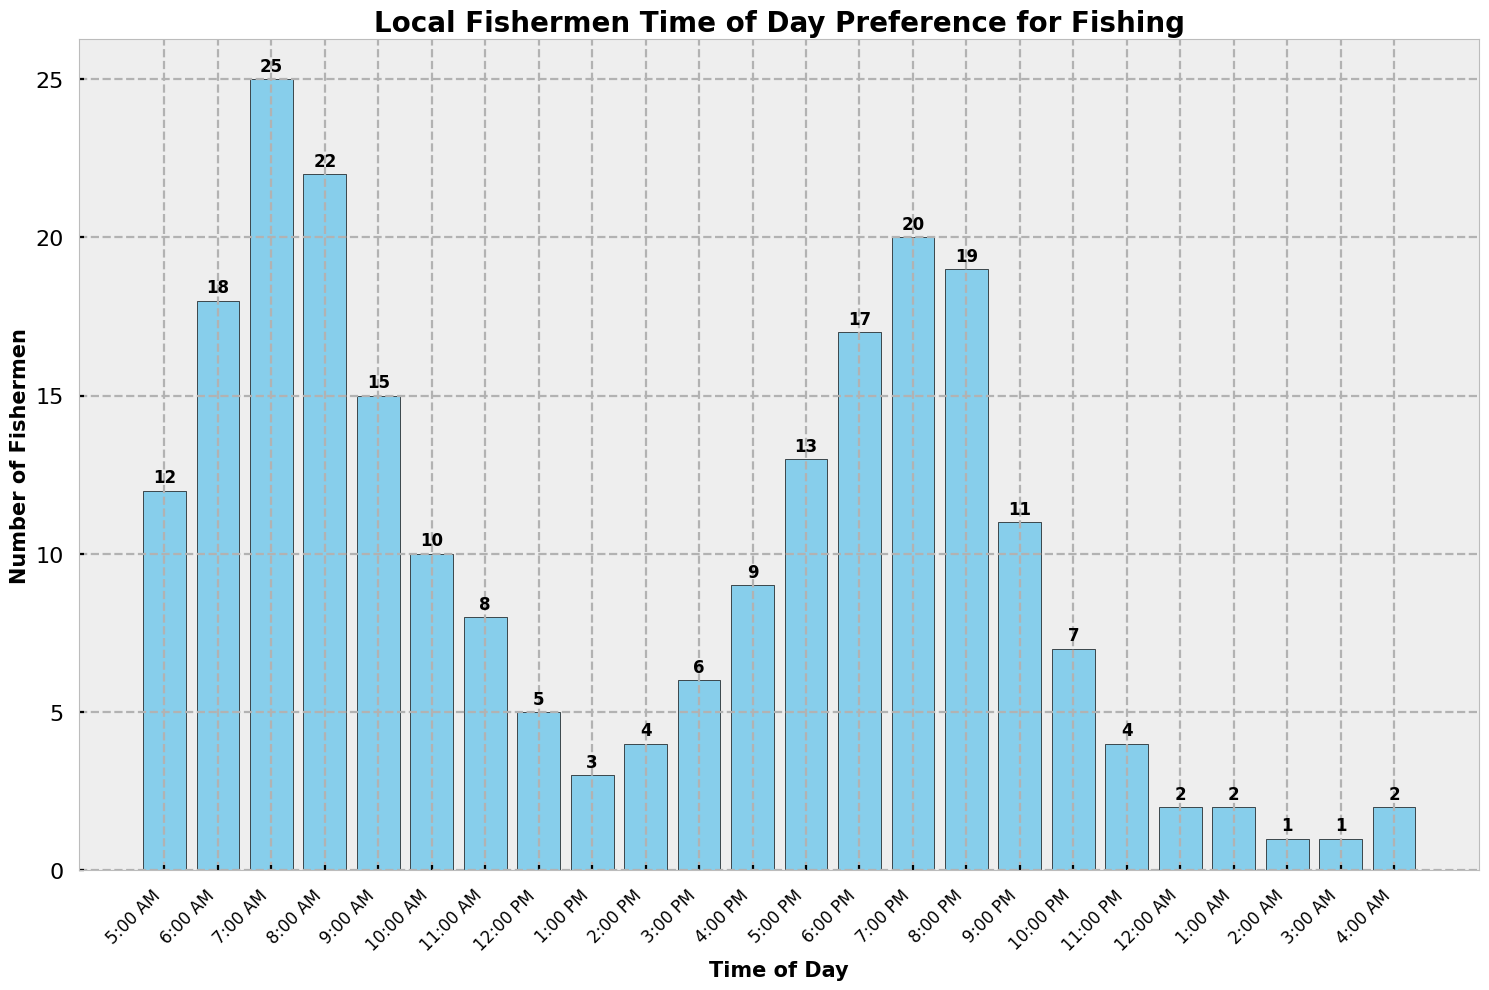What is the most preferred time of day for local fishermen to fish? The tallest bar on the histogram represents the time with the highest count of fishermen. The 7:00 AM bar is the tallest, showing that 25 fishermen prefer this time.
Answer: 7:00 AM How many fishermen prefer to fish between 5:00 AM and 7:00 AM? Sum the counts for the bars labeled 5:00 AM, 6:00 AM, and 7:00 AM. This is 12 + 18 + 25 = 55 fishermen.
Answer: 55 Is the count of fishermen who prefer to fish at 6:00 PM greater than those who prefer 10:00 PM? Compare the heights of the bars for 6:00 PM and 10:00 PM. 6:00 PM has 17 fishermen, while 10:00 PM has 7 fishermen. 17 is greater than 7.
Answer: Yes What is the difference in the number of fishermen between the most and least preferred times of day? Find the highest and lowest counts on the bars. The highest is at 7:00 AM with 25 fishermen, and the lowest counts are 2 fishermen at 12:00 AM, 1:00 AM, 2:00 AM, 3:00 AM, and 4:00 AM. The difference is 25 - 1 = 24.
Answer: 24 At what time range do fewer than 5 fishermen prefer to fish? Identify the bars with counts less than 5. These times are 12:00 PM (5 fishermen), 1:00 PM (3 fishermen), 2:00 PM (4 fishermen), 12:00 AM (2 fishermen), 1:00 AM (2 fishermen), 2:00 AM (1 fisherman), 3:00 AM (1 fisherman), and 4:00 AM (2 fishermen).
Answer: 12:00 PM to 2:00 PM and 12:00 AM to 4:00 AM During which time frame does the count of fishermen systematically decrease? Look for a sequence in the histogram where the counts continuously decrease. From 8:00 AM (22 fishermen) to 1:00 PM (3 fishermen), the counts decrease consistently.
Answer: 8:00 AM to 1:00 PM How many fishermen prefer fishing from 5:00 PM to 7:00 PM inclusive? Sum the counts for the bars labeled 5:00 PM, 6:00 PM, and 7:00 PM. This is 13 + 17 + 20 = 50 fishermen.
Answer: 50 Compare the preference for fishing between early morning (5:00 AM - 9:00 AM) and late evening (5:00 PM - 9:00 PM). Which time is more popular and by how much? Sum the counts for each period. Early morning: 12 + 18 + 25 + 22 + 15 = 92 fishermen. Late evening: 13 + 17 + 20 + 19 + 11 = 80 fishermen. Early morning is more popular by 92 - 80 = 12 fishermen.
Answer: Early morning by 12 fishermen What is the average number of fishermen preferring to fish between 12:00 PM and 3:00 PM? Sum the counts for the bars labeled 12:00 PM, 1:00 PM, 2:00 PM, and 3:00 PM, then divide by the number of times. This is (5 + 3 + 4 + 6) / 4 = 18 / 4 = 4.5 fishermen.
Answer: 4.5 